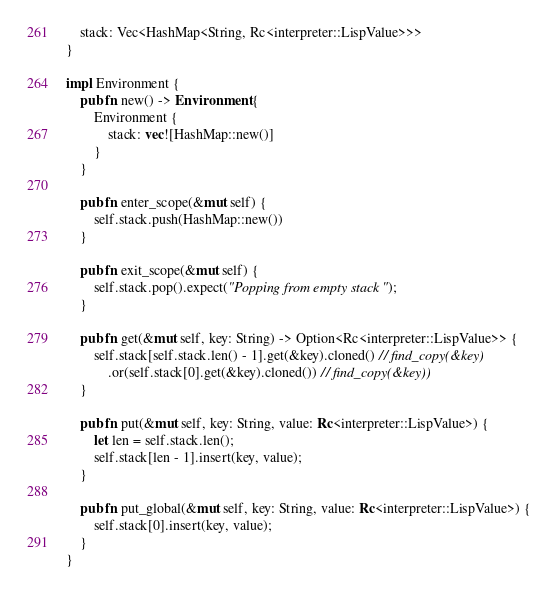<code> <loc_0><loc_0><loc_500><loc_500><_Rust_>    stack: Vec<HashMap<String, Rc<interpreter::LispValue>>>
}

impl Environment {
    pub fn new() -> Environment {
        Environment {
            stack: vec![HashMap::new()]
        }
    }

    pub fn enter_scope(&mut self) {
        self.stack.push(HashMap::new())
    }

    pub fn exit_scope(&mut self) {
        self.stack.pop().expect("Popping from empty stack");
    }

    pub fn get(&mut self, key: String) -> Option<Rc<interpreter::LispValue>> {
        self.stack[self.stack.len() - 1].get(&key).cloned() // find_copy(&key)
            .or(self.stack[0].get(&key).cloned()) // find_copy(&key))
    }

    pub fn put(&mut self, key: String, value: Rc<interpreter::LispValue>) {
        let len = self.stack.len();
        self.stack[len - 1].insert(key, value);
    }

    pub fn put_global(&mut self, key: String, value: Rc<interpreter::LispValue>) {
        self.stack[0].insert(key, value);
    }
}
</code> 